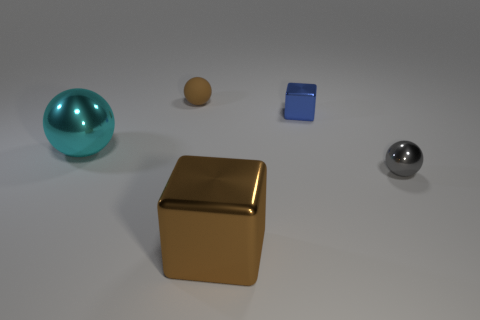Is there any other thing that is made of the same material as the small brown ball?
Your answer should be very brief. No. Is the tiny matte sphere the same color as the big metal cube?
Your response must be concise. Yes. What shape is the object in front of the metallic ball right of the brown object in front of the blue shiny block?
Offer a terse response. Cube. What number of blocks are large brown objects or blue metallic objects?
Your response must be concise. 2. There is a sphere that is to the right of the brown matte object; is it the same color as the matte thing?
Your response must be concise. No. The thing that is on the left side of the small sphere that is on the left side of the big metallic thing that is to the right of the small brown matte ball is made of what material?
Your response must be concise. Metal. Does the blue metal block have the same size as the brown block?
Ensure brevity in your answer.  No. There is a small metal ball; is its color the same as the block behind the large cube?
Offer a very short reply. No. There is a blue thing that is made of the same material as the cyan thing; what is its shape?
Give a very brief answer. Cube. There is a large shiny object that is on the left side of the big brown shiny block; is its shape the same as the blue object?
Provide a short and direct response. No. 